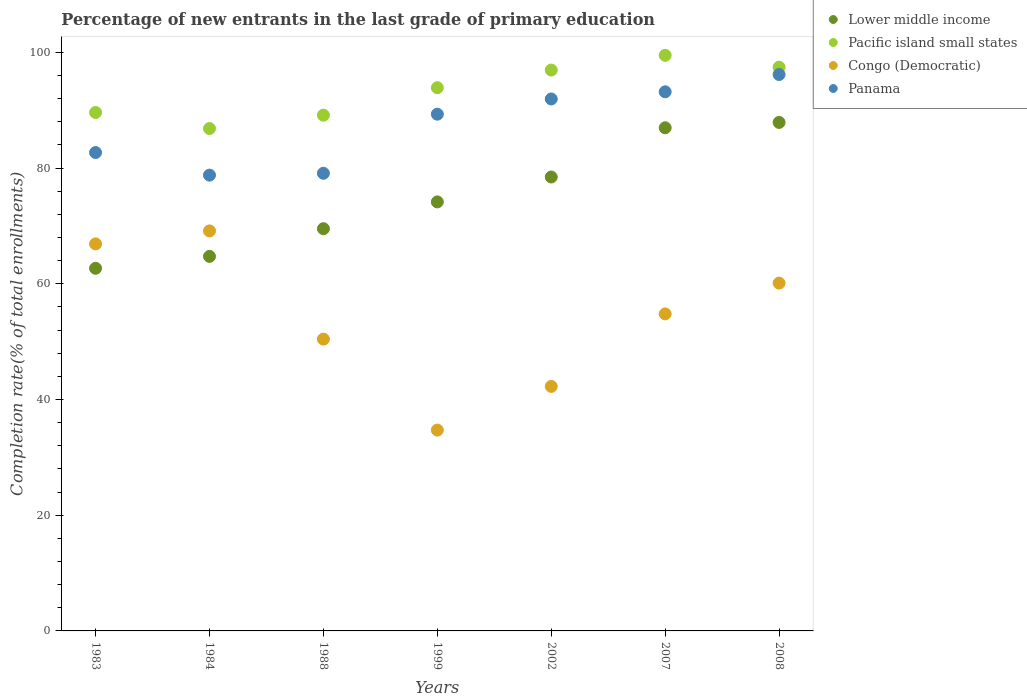Is the number of dotlines equal to the number of legend labels?
Your answer should be compact. Yes. What is the percentage of new entrants in Congo (Democratic) in 1988?
Ensure brevity in your answer.  50.44. Across all years, what is the maximum percentage of new entrants in Panama?
Provide a succinct answer. 96.17. Across all years, what is the minimum percentage of new entrants in Congo (Democratic)?
Offer a terse response. 34.71. In which year was the percentage of new entrants in Panama maximum?
Provide a short and direct response. 2008. What is the total percentage of new entrants in Panama in the graph?
Offer a very short reply. 611.19. What is the difference between the percentage of new entrants in Pacific island small states in 1983 and that in 1984?
Give a very brief answer. 2.77. What is the difference between the percentage of new entrants in Pacific island small states in 2002 and the percentage of new entrants in Lower middle income in 2007?
Your response must be concise. 9.98. What is the average percentage of new entrants in Pacific island small states per year?
Your answer should be very brief. 93.34. In the year 2002, what is the difference between the percentage of new entrants in Congo (Democratic) and percentage of new entrants in Panama?
Provide a succinct answer. -49.68. In how many years, is the percentage of new entrants in Congo (Democratic) greater than 24 %?
Keep it short and to the point. 7. What is the ratio of the percentage of new entrants in Congo (Democratic) in 1983 to that in 2002?
Your response must be concise. 1.58. Is the percentage of new entrants in Lower middle income in 1983 less than that in 1988?
Give a very brief answer. Yes. What is the difference between the highest and the second highest percentage of new entrants in Congo (Democratic)?
Keep it short and to the point. 2.25. What is the difference between the highest and the lowest percentage of new entrants in Panama?
Keep it short and to the point. 17.39. Is it the case that in every year, the sum of the percentage of new entrants in Panama and percentage of new entrants in Lower middle income  is greater than the sum of percentage of new entrants in Congo (Democratic) and percentage of new entrants in Pacific island small states?
Your answer should be very brief. No. Does the percentage of new entrants in Lower middle income monotonically increase over the years?
Your response must be concise. Yes. Is the percentage of new entrants in Congo (Democratic) strictly less than the percentage of new entrants in Panama over the years?
Provide a short and direct response. Yes. How many dotlines are there?
Your answer should be compact. 4. How many years are there in the graph?
Provide a succinct answer. 7. What is the difference between two consecutive major ticks on the Y-axis?
Your answer should be compact. 20. Are the values on the major ticks of Y-axis written in scientific E-notation?
Keep it short and to the point. No. Does the graph contain any zero values?
Provide a short and direct response. No. Where does the legend appear in the graph?
Offer a terse response. Top right. What is the title of the graph?
Offer a terse response. Percentage of new entrants in the last grade of primary education. What is the label or title of the Y-axis?
Your response must be concise. Completion rate(% of total enrollments). What is the Completion rate(% of total enrollments) in Lower middle income in 1983?
Provide a short and direct response. 62.68. What is the Completion rate(% of total enrollments) in Pacific island small states in 1983?
Keep it short and to the point. 89.61. What is the Completion rate(% of total enrollments) in Congo (Democratic) in 1983?
Ensure brevity in your answer.  66.89. What is the Completion rate(% of total enrollments) in Panama in 1983?
Provide a succinct answer. 82.69. What is the Completion rate(% of total enrollments) of Lower middle income in 1984?
Give a very brief answer. 64.73. What is the Completion rate(% of total enrollments) of Pacific island small states in 1984?
Provide a succinct answer. 86.84. What is the Completion rate(% of total enrollments) of Congo (Democratic) in 1984?
Provide a succinct answer. 69.14. What is the Completion rate(% of total enrollments) of Panama in 1984?
Offer a terse response. 78.78. What is the Completion rate(% of total enrollments) in Lower middle income in 1988?
Your answer should be very brief. 69.53. What is the Completion rate(% of total enrollments) of Pacific island small states in 1988?
Make the answer very short. 89.15. What is the Completion rate(% of total enrollments) of Congo (Democratic) in 1988?
Ensure brevity in your answer.  50.44. What is the Completion rate(% of total enrollments) in Panama in 1988?
Ensure brevity in your answer.  79.1. What is the Completion rate(% of total enrollments) in Lower middle income in 1999?
Your response must be concise. 74.16. What is the Completion rate(% of total enrollments) of Pacific island small states in 1999?
Provide a succinct answer. 93.9. What is the Completion rate(% of total enrollments) of Congo (Democratic) in 1999?
Offer a terse response. 34.71. What is the Completion rate(% of total enrollments) in Panama in 1999?
Keep it short and to the point. 89.32. What is the Completion rate(% of total enrollments) of Lower middle income in 2002?
Make the answer very short. 78.46. What is the Completion rate(% of total enrollments) of Pacific island small states in 2002?
Make the answer very short. 96.95. What is the Completion rate(% of total enrollments) of Congo (Democratic) in 2002?
Give a very brief answer. 42.26. What is the Completion rate(% of total enrollments) in Panama in 2002?
Keep it short and to the point. 91.95. What is the Completion rate(% of total enrollments) of Lower middle income in 2007?
Provide a succinct answer. 86.97. What is the Completion rate(% of total enrollments) of Pacific island small states in 2007?
Keep it short and to the point. 99.49. What is the Completion rate(% of total enrollments) in Congo (Democratic) in 2007?
Keep it short and to the point. 54.8. What is the Completion rate(% of total enrollments) in Panama in 2007?
Offer a very short reply. 93.18. What is the Completion rate(% of total enrollments) in Lower middle income in 2008?
Your answer should be compact. 87.89. What is the Completion rate(% of total enrollments) of Pacific island small states in 2008?
Offer a terse response. 97.44. What is the Completion rate(% of total enrollments) in Congo (Democratic) in 2008?
Keep it short and to the point. 60.12. What is the Completion rate(% of total enrollments) of Panama in 2008?
Give a very brief answer. 96.17. Across all years, what is the maximum Completion rate(% of total enrollments) of Lower middle income?
Your response must be concise. 87.89. Across all years, what is the maximum Completion rate(% of total enrollments) of Pacific island small states?
Keep it short and to the point. 99.49. Across all years, what is the maximum Completion rate(% of total enrollments) of Congo (Democratic)?
Keep it short and to the point. 69.14. Across all years, what is the maximum Completion rate(% of total enrollments) of Panama?
Your answer should be very brief. 96.17. Across all years, what is the minimum Completion rate(% of total enrollments) in Lower middle income?
Keep it short and to the point. 62.68. Across all years, what is the minimum Completion rate(% of total enrollments) of Pacific island small states?
Keep it short and to the point. 86.84. Across all years, what is the minimum Completion rate(% of total enrollments) in Congo (Democratic)?
Offer a very short reply. 34.71. Across all years, what is the minimum Completion rate(% of total enrollments) in Panama?
Ensure brevity in your answer.  78.78. What is the total Completion rate(% of total enrollments) in Lower middle income in the graph?
Ensure brevity in your answer.  524.41. What is the total Completion rate(% of total enrollments) of Pacific island small states in the graph?
Your answer should be very brief. 653.37. What is the total Completion rate(% of total enrollments) in Congo (Democratic) in the graph?
Ensure brevity in your answer.  378.36. What is the total Completion rate(% of total enrollments) in Panama in the graph?
Offer a terse response. 611.19. What is the difference between the Completion rate(% of total enrollments) of Lower middle income in 1983 and that in 1984?
Offer a very short reply. -2.06. What is the difference between the Completion rate(% of total enrollments) in Pacific island small states in 1983 and that in 1984?
Give a very brief answer. 2.77. What is the difference between the Completion rate(% of total enrollments) in Congo (Democratic) in 1983 and that in 1984?
Offer a very short reply. -2.25. What is the difference between the Completion rate(% of total enrollments) in Panama in 1983 and that in 1984?
Offer a terse response. 3.9. What is the difference between the Completion rate(% of total enrollments) in Lower middle income in 1983 and that in 1988?
Offer a terse response. -6.85. What is the difference between the Completion rate(% of total enrollments) of Pacific island small states in 1983 and that in 1988?
Provide a short and direct response. 0.46. What is the difference between the Completion rate(% of total enrollments) of Congo (Democratic) in 1983 and that in 1988?
Keep it short and to the point. 16.46. What is the difference between the Completion rate(% of total enrollments) in Panama in 1983 and that in 1988?
Give a very brief answer. 3.58. What is the difference between the Completion rate(% of total enrollments) of Lower middle income in 1983 and that in 1999?
Your response must be concise. -11.48. What is the difference between the Completion rate(% of total enrollments) of Pacific island small states in 1983 and that in 1999?
Keep it short and to the point. -4.28. What is the difference between the Completion rate(% of total enrollments) in Congo (Democratic) in 1983 and that in 1999?
Offer a terse response. 32.18. What is the difference between the Completion rate(% of total enrollments) in Panama in 1983 and that in 1999?
Provide a short and direct response. -6.63. What is the difference between the Completion rate(% of total enrollments) in Lower middle income in 1983 and that in 2002?
Your answer should be very brief. -15.78. What is the difference between the Completion rate(% of total enrollments) in Pacific island small states in 1983 and that in 2002?
Provide a short and direct response. -7.33. What is the difference between the Completion rate(% of total enrollments) in Congo (Democratic) in 1983 and that in 2002?
Offer a very short reply. 24.63. What is the difference between the Completion rate(% of total enrollments) in Panama in 1983 and that in 2002?
Offer a terse response. -9.26. What is the difference between the Completion rate(% of total enrollments) of Lower middle income in 1983 and that in 2007?
Your answer should be compact. -24.29. What is the difference between the Completion rate(% of total enrollments) in Pacific island small states in 1983 and that in 2007?
Your answer should be compact. -9.88. What is the difference between the Completion rate(% of total enrollments) in Congo (Democratic) in 1983 and that in 2007?
Make the answer very short. 12.1. What is the difference between the Completion rate(% of total enrollments) of Panama in 1983 and that in 2007?
Keep it short and to the point. -10.5. What is the difference between the Completion rate(% of total enrollments) in Lower middle income in 1983 and that in 2008?
Ensure brevity in your answer.  -25.21. What is the difference between the Completion rate(% of total enrollments) in Pacific island small states in 1983 and that in 2008?
Provide a succinct answer. -7.83. What is the difference between the Completion rate(% of total enrollments) of Congo (Democratic) in 1983 and that in 2008?
Keep it short and to the point. 6.78. What is the difference between the Completion rate(% of total enrollments) of Panama in 1983 and that in 2008?
Your answer should be compact. -13.49. What is the difference between the Completion rate(% of total enrollments) of Lower middle income in 1984 and that in 1988?
Your response must be concise. -4.79. What is the difference between the Completion rate(% of total enrollments) of Pacific island small states in 1984 and that in 1988?
Make the answer very short. -2.31. What is the difference between the Completion rate(% of total enrollments) in Congo (Democratic) in 1984 and that in 1988?
Provide a short and direct response. 18.71. What is the difference between the Completion rate(% of total enrollments) in Panama in 1984 and that in 1988?
Offer a very short reply. -0.32. What is the difference between the Completion rate(% of total enrollments) in Lower middle income in 1984 and that in 1999?
Give a very brief answer. -9.42. What is the difference between the Completion rate(% of total enrollments) in Pacific island small states in 1984 and that in 1999?
Your answer should be very brief. -7.06. What is the difference between the Completion rate(% of total enrollments) in Congo (Democratic) in 1984 and that in 1999?
Your answer should be compact. 34.43. What is the difference between the Completion rate(% of total enrollments) of Panama in 1984 and that in 1999?
Give a very brief answer. -10.54. What is the difference between the Completion rate(% of total enrollments) of Lower middle income in 1984 and that in 2002?
Ensure brevity in your answer.  -13.72. What is the difference between the Completion rate(% of total enrollments) in Pacific island small states in 1984 and that in 2002?
Your answer should be very brief. -10.11. What is the difference between the Completion rate(% of total enrollments) of Congo (Democratic) in 1984 and that in 2002?
Offer a terse response. 26.88. What is the difference between the Completion rate(% of total enrollments) in Panama in 1984 and that in 2002?
Offer a very short reply. -13.16. What is the difference between the Completion rate(% of total enrollments) of Lower middle income in 1984 and that in 2007?
Provide a succinct answer. -22.23. What is the difference between the Completion rate(% of total enrollments) in Pacific island small states in 1984 and that in 2007?
Provide a succinct answer. -12.65. What is the difference between the Completion rate(% of total enrollments) of Congo (Democratic) in 1984 and that in 2007?
Your answer should be compact. 14.34. What is the difference between the Completion rate(% of total enrollments) of Panama in 1984 and that in 2007?
Your answer should be compact. -14.4. What is the difference between the Completion rate(% of total enrollments) in Lower middle income in 1984 and that in 2008?
Offer a very short reply. -23.16. What is the difference between the Completion rate(% of total enrollments) of Pacific island small states in 1984 and that in 2008?
Provide a succinct answer. -10.6. What is the difference between the Completion rate(% of total enrollments) of Congo (Democratic) in 1984 and that in 2008?
Your answer should be very brief. 9.02. What is the difference between the Completion rate(% of total enrollments) of Panama in 1984 and that in 2008?
Keep it short and to the point. -17.39. What is the difference between the Completion rate(% of total enrollments) of Lower middle income in 1988 and that in 1999?
Your answer should be very brief. -4.63. What is the difference between the Completion rate(% of total enrollments) of Pacific island small states in 1988 and that in 1999?
Provide a succinct answer. -4.75. What is the difference between the Completion rate(% of total enrollments) of Congo (Democratic) in 1988 and that in 1999?
Keep it short and to the point. 15.72. What is the difference between the Completion rate(% of total enrollments) of Panama in 1988 and that in 1999?
Ensure brevity in your answer.  -10.22. What is the difference between the Completion rate(% of total enrollments) of Lower middle income in 1988 and that in 2002?
Make the answer very short. -8.93. What is the difference between the Completion rate(% of total enrollments) of Pacific island small states in 1988 and that in 2002?
Your response must be concise. -7.8. What is the difference between the Completion rate(% of total enrollments) in Congo (Democratic) in 1988 and that in 2002?
Offer a terse response. 8.17. What is the difference between the Completion rate(% of total enrollments) in Panama in 1988 and that in 2002?
Offer a terse response. -12.84. What is the difference between the Completion rate(% of total enrollments) in Lower middle income in 1988 and that in 2007?
Your response must be concise. -17.44. What is the difference between the Completion rate(% of total enrollments) of Pacific island small states in 1988 and that in 2007?
Provide a succinct answer. -10.35. What is the difference between the Completion rate(% of total enrollments) in Congo (Democratic) in 1988 and that in 2007?
Your response must be concise. -4.36. What is the difference between the Completion rate(% of total enrollments) in Panama in 1988 and that in 2007?
Your response must be concise. -14.08. What is the difference between the Completion rate(% of total enrollments) in Lower middle income in 1988 and that in 2008?
Give a very brief answer. -18.37. What is the difference between the Completion rate(% of total enrollments) of Pacific island small states in 1988 and that in 2008?
Provide a short and direct response. -8.29. What is the difference between the Completion rate(% of total enrollments) of Congo (Democratic) in 1988 and that in 2008?
Offer a terse response. -9.68. What is the difference between the Completion rate(% of total enrollments) of Panama in 1988 and that in 2008?
Provide a short and direct response. -17.07. What is the difference between the Completion rate(% of total enrollments) in Lower middle income in 1999 and that in 2002?
Keep it short and to the point. -4.3. What is the difference between the Completion rate(% of total enrollments) of Pacific island small states in 1999 and that in 2002?
Your response must be concise. -3.05. What is the difference between the Completion rate(% of total enrollments) in Congo (Democratic) in 1999 and that in 2002?
Provide a succinct answer. -7.55. What is the difference between the Completion rate(% of total enrollments) of Panama in 1999 and that in 2002?
Provide a short and direct response. -2.63. What is the difference between the Completion rate(% of total enrollments) of Lower middle income in 1999 and that in 2007?
Offer a very short reply. -12.81. What is the difference between the Completion rate(% of total enrollments) in Pacific island small states in 1999 and that in 2007?
Your response must be concise. -5.6. What is the difference between the Completion rate(% of total enrollments) in Congo (Democratic) in 1999 and that in 2007?
Offer a very short reply. -20.08. What is the difference between the Completion rate(% of total enrollments) in Panama in 1999 and that in 2007?
Ensure brevity in your answer.  -3.87. What is the difference between the Completion rate(% of total enrollments) of Lower middle income in 1999 and that in 2008?
Give a very brief answer. -13.73. What is the difference between the Completion rate(% of total enrollments) in Pacific island small states in 1999 and that in 2008?
Your response must be concise. -3.54. What is the difference between the Completion rate(% of total enrollments) in Congo (Democratic) in 1999 and that in 2008?
Give a very brief answer. -25.4. What is the difference between the Completion rate(% of total enrollments) of Panama in 1999 and that in 2008?
Keep it short and to the point. -6.86. What is the difference between the Completion rate(% of total enrollments) of Lower middle income in 2002 and that in 2007?
Provide a short and direct response. -8.51. What is the difference between the Completion rate(% of total enrollments) in Pacific island small states in 2002 and that in 2007?
Give a very brief answer. -2.55. What is the difference between the Completion rate(% of total enrollments) of Congo (Democratic) in 2002 and that in 2007?
Your answer should be compact. -12.54. What is the difference between the Completion rate(% of total enrollments) in Panama in 2002 and that in 2007?
Provide a succinct answer. -1.24. What is the difference between the Completion rate(% of total enrollments) in Lower middle income in 2002 and that in 2008?
Provide a short and direct response. -9.43. What is the difference between the Completion rate(% of total enrollments) of Pacific island small states in 2002 and that in 2008?
Your answer should be very brief. -0.49. What is the difference between the Completion rate(% of total enrollments) of Congo (Democratic) in 2002 and that in 2008?
Keep it short and to the point. -17.86. What is the difference between the Completion rate(% of total enrollments) in Panama in 2002 and that in 2008?
Ensure brevity in your answer.  -4.23. What is the difference between the Completion rate(% of total enrollments) of Lower middle income in 2007 and that in 2008?
Offer a terse response. -0.92. What is the difference between the Completion rate(% of total enrollments) in Pacific island small states in 2007 and that in 2008?
Your response must be concise. 2.05. What is the difference between the Completion rate(% of total enrollments) of Congo (Democratic) in 2007 and that in 2008?
Your answer should be very brief. -5.32. What is the difference between the Completion rate(% of total enrollments) in Panama in 2007 and that in 2008?
Offer a very short reply. -2.99. What is the difference between the Completion rate(% of total enrollments) in Lower middle income in 1983 and the Completion rate(% of total enrollments) in Pacific island small states in 1984?
Your answer should be compact. -24.16. What is the difference between the Completion rate(% of total enrollments) in Lower middle income in 1983 and the Completion rate(% of total enrollments) in Congo (Democratic) in 1984?
Your answer should be very brief. -6.46. What is the difference between the Completion rate(% of total enrollments) of Lower middle income in 1983 and the Completion rate(% of total enrollments) of Panama in 1984?
Give a very brief answer. -16.1. What is the difference between the Completion rate(% of total enrollments) of Pacific island small states in 1983 and the Completion rate(% of total enrollments) of Congo (Democratic) in 1984?
Keep it short and to the point. 20.47. What is the difference between the Completion rate(% of total enrollments) in Pacific island small states in 1983 and the Completion rate(% of total enrollments) in Panama in 1984?
Make the answer very short. 10.83. What is the difference between the Completion rate(% of total enrollments) in Congo (Democratic) in 1983 and the Completion rate(% of total enrollments) in Panama in 1984?
Keep it short and to the point. -11.89. What is the difference between the Completion rate(% of total enrollments) of Lower middle income in 1983 and the Completion rate(% of total enrollments) of Pacific island small states in 1988?
Give a very brief answer. -26.47. What is the difference between the Completion rate(% of total enrollments) in Lower middle income in 1983 and the Completion rate(% of total enrollments) in Congo (Democratic) in 1988?
Provide a succinct answer. 12.24. What is the difference between the Completion rate(% of total enrollments) in Lower middle income in 1983 and the Completion rate(% of total enrollments) in Panama in 1988?
Your response must be concise. -16.42. What is the difference between the Completion rate(% of total enrollments) in Pacific island small states in 1983 and the Completion rate(% of total enrollments) in Congo (Democratic) in 1988?
Offer a terse response. 39.18. What is the difference between the Completion rate(% of total enrollments) in Pacific island small states in 1983 and the Completion rate(% of total enrollments) in Panama in 1988?
Provide a succinct answer. 10.51. What is the difference between the Completion rate(% of total enrollments) of Congo (Democratic) in 1983 and the Completion rate(% of total enrollments) of Panama in 1988?
Offer a very short reply. -12.21. What is the difference between the Completion rate(% of total enrollments) of Lower middle income in 1983 and the Completion rate(% of total enrollments) of Pacific island small states in 1999?
Your answer should be compact. -31.22. What is the difference between the Completion rate(% of total enrollments) of Lower middle income in 1983 and the Completion rate(% of total enrollments) of Congo (Democratic) in 1999?
Provide a short and direct response. 27.97. What is the difference between the Completion rate(% of total enrollments) of Lower middle income in 1983 and the Completion rate(% of total enrollments) of Panama in 1999?
Offer a terse response. -26.64. What is the difference between the Completion rate(% of total enrollments) of Pacific island small states in 1983 and the Completion rate(% of total enrollments) of Congo (Democratic) in 1999?
Ensure brevity in your answer.  54.9. What is the difference between the Completion rate(% of total enrollments) in Pacific island small states in 1983 and the Completion rate(% of total enrollments) in Panama in 1999?
Ensure brevity in your answer.  0.29. What is the difference between the Completion rate(% of total enrollments) of Congo (Democratic) in 1983 and the Completion rate(% of total enrollments) of Panama in 1999?
Give a very brief answer. -22.42. What is the difference between the Completion rate(% of total enrollments) of Lower middle income in 1983 and the Completion rate(% of total enrollments) of Pacific island small states in 2002?
Keep it short and to the point. -34.27. What is the difference between the Completion rate(% of total enrollments) in Lower middle income in 1983 and the Completion rate(% of total enrollments) in Congo (Democratic) in 2002?
Make the answer very short. 20.42. What is the difference between the Completion rate(% of total enrollments) in Lower middle income in 1983 and the Completion rate(% of total enrollments) in Panama in 2002?
Your answer should be very brief. -29.27. What is the difference between the Completion rate(% of total enrollments) of Pacific island small states in 1983 and the Completion rate(% of total enrollments) of Congo (Democratic) in 2002?
Offer a very short reply. 47.35. What is the difference between the Completion rate(% of total enrollments) in Pacific island small states in 1983 and the Completion rate(% of total enrollments) in Panama in 2002?
Make the answer very short. -2.33. What is the difference between the Completion rate(% of total enrollments) in Congo (Democratic) in 1983 and the Completion rate(% of total enrollments) in Panama in 2002?
Your answer should be very brief. -25.05. What is the difference between the Completion rate(% of total enrollments) in Lower middle income in 1983 and the Completion rate(% of total enrollments) in Pacific island small states in 2007?
Provide a short and direct response. -36.81. What is the difference between the Completion rate(% of total enrollments) in Lower middle income in 1983 and the Completion rate(% of total enrollments) in Congo (Democratic) in 2007?
Your answer should be compact. 7.88. What is the difference between the Completion rate(% of total enrollments) in Lower middle income in 1983 and the Completion rate(% of total enrollments) in Panama in 2007?
Offer a very short reply. -30.51. What is the difference between the Completion rate(% of total enrollments) in Pacific island small states in 1983 and the Completion rate(% of total enrollments) in Congo (Democratic) in 2007?
Make the answer very short. 34.81. What is the difference between the Completion rate(% of total enrollments) of Pacific island small states in 1983 and the Completion rate(% of total enrollments) of Panama in 2007?
Your response must be concise. -3.57. What is the difference between the Completion rate(% of total enrollments) of Congo (Democratic) in 1983 and the Completion rate(% of total enrollments) of Panama in 2007?
Your answer should be very brief. -26.29. What is the difference between the Completion rate(% of total enrollments) of Lower middle income in 1983 and the Completion rate(% of total enrollments) of Pacific island small states in 2008?
Your answer should be compact. -34.76. What is the difference between the Completion rate(% of total enrollments) in Lower middle income in 1983 and the Completion rate(% of total enrollments) in Congo (Democratic) in 2008?
Give a very brief answer. 2.56. What is the difference between the Completion rate(% of total enrollments) of Lower middle income in 1983 and the Completion rate(% of total enrollments) of Panama in 2008?
Give a very brief answer. -33.5. What is the difference between the Completion rate(% of total enrollments) of Pacific island small states in 1983 and the Completion rate(% of total enrollments) of Congo (Democratic) in 2008?
Your answer should be compact. 29.49. What is the difference between the Completion rate(% of total enrollments) of Pacific island small states in 1983 and the Completion rate(% of total enrollments) of Panama in 2008?
Keep it short and to the point. -6.56. What is the difference between the Completion rate(% of total enrollments) in Congo (Democratic) in 1983 and the Completion rate(% of total enrollments) in Panama in 2008?
Your answer should be compact. -29.28. What is the difference between the Completion rate(% of total enrollments) of Lower middle income in 1984 and the Completion rate(% of total enrollments) of Pacific island small states in 1988?
Your response must be concise. -24.41. What is the difference between the Completion rate(% of total enrollments) in Lower middle income in 1984 and the Completion rate(% of total enrollments) in Congo (Democratic) in 1988?
Make the answer very short. 14.3. What is the difference between the Completion rate(% of total enrollments) of Lower middle income in 1984 and the Completion rate(% of total enrollments) of Panama in 1988?
Your response must be concise. -14.37. What is the difference between the Completion rate(% of total enrollments) in Pacific island small states in 1984 and the Completion rate(% of total enrollments) in Congo (Democratic) in 1988?
Your answer should be very brief. 36.4. What is the difference between the Completion rate(% of total enrollments) of Pacific island small states in 1984 and the Completion rate(% of total enrollments) of Panama in 1988?
Offer a very short reply. 7.73. What is the difference between the Completion rate(% of total enrollments) in Congo (Democratic) in 1984 and the Completion rate(% of total enrollments) in Panama in 1988?
Give a very brief answer. -9.96. What is the difference between the Completion rate(% of total enrollments) in Lower middle income in 1984 and the Completion rate(% of total enrollments) in Pacific island small states in 1999?
Your answer should be compact. -29.16. What is the difference between the Completion rate(% of total enrollments) of Lower middle income in 1984 and the Completion rate(% of total enrollments) of Congo (Democratic) in 1999?
Your answer should be compact. 30.02. What is the difference between the Completion rate(% of total enrollments) in Lower middle income in 1984 and the Completion rate(% of total enrollments) in Panama in 1999?
Provide a succinct answer. -24.58. What is the difference between the Completion rate(% of total enrollments) of Pacific island small states in 1984 and the Completion rate(% of total enrollments) of Congo (Democratic) in 1999?
Offer a very short reply. 52.12. What is the difference between the Completion rate(% of total enrollments) in Pacific island small states in 1984 and the Completion rate(% of total enrollments) in Panama in 1999?
Ensure brevity in your answer.  -2.48. What is the difference between the Completion rate(% of total enrollments) in Congo (Democratic) in 1984 and the Completion rate(% of total enrollments) in Panama in 1999?
Give a very brief answer. -20.18. What is the difference between the Completion rate(% of total enrollments) of Lower middle income in 1984 and the Completion rate(% of total enrollments) of Pacific island small states in 2002?
Your answer should be compact. -32.21. What is the difference between the Completion rate(% of total enrollments) of Lower middle income in 1984 and the Completion rate(% of total enrollments) of Congo (Democratic) in 2002?
Provide a succinct answer. 22.47. What is the difference between the Completion rate(% of total enrollments) in Lower middle income in 1984 and the Completion rate(% of total enrollments) in Panama in 2002?
Ensure brevity in your answer.  -27.21. What is the difference between the Completion rate(% of total enrollments) of Pacific island small states in 1984 and the Completion rate(% of total enrollments) of Congo (Democratic) in 2002?
Offer a terse response. 44.58. What is the difference between the Completion rate(% of total enrollments) of Pacific island small states in 1984 and the Completion rate(% of total enrollments) of Panama in 2002?
Ensure brevity in your answer.  -5.11. What is the difference between the Completion rate(% of total enrollments) in Congo (Democratic) in 1984 and the Completion rate(% of total enrollments) in Panama in 2002?
Offer a very short reply. -22.8. What is the difference between the Completion rate(% of total enrollments) in Lower middle income in 1984 and the Completion rate(% of total enrollments) in Pacific island small states in 2007?
Provide a short and direct response. -34.76. What is the difference between the Completion rate(% of total enrollments) in Lower middle income in 1984 and the Completion rate(% of total enrollments) in Congo (Democratic) in 2007?
Ensure brevity in your answer.  9.94. What is the difference between the Completion rate(% of total enrollments) in Lower middle income in 1984 and the Completion rate(% of total enrollments) in Panama in 2007?
Keep it short and to the point. -28.45. What is the difference between the Completion rate(% of total enrollments) in Pacific island small states in 1984 and the Completion rate(% of total enrollments) in Congo (Democratic) in 2007?
Offer a very short reply. 32.04. What is the difference between the Completion rate(% of total enrollments) in Pacific island small states in 1984 and the Completion rate(% of total enrollments) in Panama in 2007?
Offer a very short reply. -6.35. What is the difference between the Completion rate(% of total enrollments) of Congo (Democratic) in 1984 and the Completion rate(% of total enrollments) of Panama in 2007?
Ensure brevity in your answer.  -24.04. What is the difference between the Completion rate(% of total enrollments) of Lower middle income in 1984 and the Completion rate(% of total enrollments) of Pacific island small states in 2008?
Provide a short and direct response. -32.7. What is the difference between the Completion rate(% of total enrollments) in Lower middle income in 1984 and the Completion rate(% of total enrollments) in Congo (Democratic) in 2008?
Provide a short and direct response. 4.62. What is the difference between the Completion rate(% of total enrollments) in Lower middle income in 1984 and the Completion rate(% of total enrollments) in Panama in 2008?
Offer a terse response. -31.44. What is the difference between the Completion rate(% of total enrollments) of Pacific island small states in 1984 and the Completion rate(% of total enrollments) of Congo (Democratic) in 2008?
Provide a short and direct response. 26.72. What is the difference between the Completion rate(% of total enrollments) in Pacific island small states in 1984 and the Completion rate(% of total enrollments) in Panama in 2008?
Your answer should be very brief. -9.34. What is the difference between the Completion rate(% of total enrollments) of Congo (Democratic) in 1984 and the Completion rate(% of total enrollments) of Panama in 2008?
Provide a short and direct response. -27.03. What is the difference between the Completion rate(% of total enrollments) of Lower middle income in 1988 and the Completion rate(% of total enrollments) of Pacific island small states in 1999?
Offer a very short reply. -24.37. What is the difference between the Completion rate(% of total enrollments) of Lower middle income in 1988 and the Completion rate(% of total enrollments) of Congo (Democratic) in 1999?
Provide a short and direct response. 34.81. What is the difference between the Completion rate(% of total enrollments) of Lower middle income in 1988 and the Completion rate(% of total enrollments) of Panama in 1999?
Offer a terse response. -19.79. What is the difference between the Completion rate(% of total enrollments) in Pacific island small states in 1988 and the Completion rate(% of total enrollments) in Congo (Democratic) in 1999?
Keep it short and to the point. 54.43. What is the difference between the Completion rate(% of total enrollments) of Pacific island small states in 1988 and the Completion rate(% of total enrollments) of Panama in 1999?
Provide a succinct answer. -0.17. What is the difference between the Completion rate(% of total enrollments) in Congo (Democratic) in 1988 and the Completion rate(% of total enrollments) in Panama in 1999?
Offer a very short reply. -38.88. What is the difference between the Completion rate(% of total enrollments) of Lower middle income in 1988 and the Completion rate(% of total enrollments) of Pacific island small states in 2002?
Your answer should be very brief. -27.42. What is the difference between the Completion rate(% of total enrollments) of Lower middle income in 1988 and the Completion rate(% of total enrollments) of Congo (Democratic) in 2002?
Your answer should be compact. 27.26. What is the difference between the Completion rate(% of total enrollments) of Lower middle income in 1988 and the Completion rate(% of total enrollments) of Panama in 2002?
Give a very brief answer. -22.42. What is the difference between the Completion rate(% of total enrollments) in Pacific island small states in 1988 and the Completion rate(% of total enrollments) in Congo (Democratic) in 2002?
Provide a short and direct response. 46.89. What is the difference between the Completion rate(% of total enrollments) of Pacific island small states in 1988 and the Completion rate(% of total enrollments) of Panama in 2002?
Provide a succinct answer. -2.8. What is the difference between the Completion rate(% of total enrollments) in Congo (Democratic) in 1988 and the Completion rate(% of total enrollments) in Panama in 2002?
Offer a terse response. -41.51. What is the difference between the Completion rate(% of total enrollments) in Lower middle income in 1988 and the Completion rate(% of total enrollments) in Pacific island small states in 2007?
Ensure brevity in your answer.  -29.97. What is the difference between the Completion rate(% of total enrollments) of Lower middle income in 1988 and the Completion rate(% of total enrollments) of Congo (Democratic) in 2007?
Your answer should be very brief. 14.73. What is the difference between the Completion rate(% of total enrollments) in Lower middle income in 1988 and the Completion rate(% of total enrollments) in Panama in 2007?
Provide a short and direct response. -23.66. What is the difference between the Completion rate(% of total enrollments) in Pacific island small states in 1988 and the Completion rate(% of total enrollments) in Congo (Democratic) in 2007?
Make the answer very short. 34.35. What is the difference between the Completion rate(% of total enrollments) in Pacific island small states in 1988 and the Completion rate(% of total enrollments) in Panama in 2007?
Keep it short and to the point. -4.04. What is the difference between the Completion rate(% of total enrollments) of Congo (Democratic) in 1988 and the Completion rate(% of total enrollments) of Panama in 2007?
Your answer should be compact. -42.75. What is the difference between the Completion rate(% of total enrollments) of Lower middle income in 1988 and the Completion rate(% of total enrollments) of Pacific island small states in 2008?
Your answer should be very brief. -27.91. What is the difference between the Completion rate(% of total enrollments) of Lower middle income in 1988 and the Completion rate(% of total enrollments) of Congo (Democratic) in 2008?
Ensure brevity in your answer.  9.41. What is the difference between the Completion rate(% of total enrollments) in Lower middle income in 1988 and the Completion rate(% of total enrollments) in Panama in 2008?
Offer a terse response. -26.65. What is the difference between the Completion rate(% of total enrollments) in Pacific island small states in 1988 and the Completion rate(% of total enrollments) in Congo (Democratic) in 2008?
Your answer should be compact. 29.03. What is the difference between the Completion rate(% of total enrollments) of Pacific island small states in 1988 and the Completion rate(% of total enrollments) of Panama in 2008?
Your answer should be very brief. -7.03. What is the difference between the Completion rate(% of total enrollments) in Congo (Democratic) in 1988 and the Completion rate(% of total enrollments) in Panama in 2008?
Ensure brevity in your answer.  -45.74. What is the difference between the Completion rate(% of total enrollments) of Lower middle income in 1999 and the Completion rate(% of total enrollments) of Pacific island small states in 2002?
Offer a very short reply. -22.79. What is the difference between the Completion rate(% of total enrollments) in Lower middle income in 1999 and the Completion rate(% of total enrollments) in Congo (Democratic) in 2002?
Give a very brief answer. 31.89. What is the difference between the Completion rate(% of total enrollments) in Lower middle income in 1999 and the Completion rate(% of total enrollments) in Panama in 2002?
Your answer should be very brief. -17.79. What is the difference between the Completion rate(% of total enrollments) of Pacific island small states in 1999 and the Completion rate(% of total enrollments) of Congo (Democratic) in 2002?
Provide a succinct answer. 51.63. What is the difference between the Completion rate(% of total enrollments) of Pacific island small states in 1999 and the Completion rate(% of total enrollments) of Panama in 2002?
Your answer should be very brief. 1.95. What is the difference between the Completion rate(% of total enrollments) of Congo (Democratic) in 1999 and the Completion rate(% of total enrollments) of Panama in 2002?
Your answer should be very brief. -57.23. What is the difference between the Completion rate(% of total enrollments) in Lower middle income in 1999 and the Completion rate(% of total enrollments) in Pacific island small states in 2007?
Keep it short and to the point. -25.34. What is the difference between the Completion rate(% of total enrollments) of Lower middle income in 1999 and the Completion rate(% of total enrollments) of Congo (Democratic) in 2007?
Keep it short and to the point. 19.36. What is the difference between the Completion rate(% of total enrollments) in Lower middle income in 1999 and the Completion rate(% of total enrollments) in Panama in 2007?
Your answer should be compact. -19.03. What is the difference between the Completion rate(% of total enrollments) in Pacific island small states in 1999 and the Completion rate(% of total enrollments) in Congo (Democratic) in 2007?
Make the answer very short. 39.1. What is the difference between the Completion rate(% of total enrollments) of Pacific island small states in 1999 and the Completion rate(% of total enrollments) of Panama in 2007?
Your response must be concise. 0.71. What is the difference between the Completion rate(% of total enrollments) of Congo (Democratic) in 1999 and the Completion rate(% of total enrollments) of Panama in 2007?
Ensure brevity in your answer.  -58.47. What is the difference between the Completion rate(% of total enrollments) of Lower middle income in 1999 and the Completion rate(% of total enrollments) of Pacific island small states in 2008?
Offer a very short reply. -23.28. What is the difference between the Completion rate(% of total enrollments) in Lower middle income in 1999 and the Completion rate(% of total enrollments) in Congo (Democratic) in 2008?
Give a very brief answer. 14.04. What is the difference between the Completion rate(% of total enrollments) of Lower middle income in 1999 and the Completion rate(% of total enrollments) of Panama in 2008?
Provide a short and direct response. -22.02. What is the difference between the Completion rate(% of total enrollments) of Pacific island small states in 1999 and the Completion rate(% of total enrollments) of Congo (Democratic) in 2008?
Offer a very short reply. 33.78. What is the difference between the Completion rate(% of total enrollments) of Pacific island small states in 1999 and the Completion rate(% of total enrollments) of Panama in 2008?
Provide a succinct answer. -2.28. What is the difference between the Completion rate(% of total enrollments) in Congo (Democratic) in 1999 and the Completion rate(% of total enrollments) in Panama in 2008?
Your response must be concise. -61.46. What is the difference between the Completion rate(% of total enrollments) in Lower middle income in 2002 and the Completion rate(% of total enrollments) in Pacific island small states in 2007?
Your response must be concise. -21.04. What is the difference between the Completion rate(% of total enrollments) in Lower middle income in 2002 and the Completion rate(% of total enrollments) in Congo (Democratic) in 2007?
Your response must be concise. 23.66. What is the difference between the Completion rate(% of total enrollments) in Lower middle income in 2002 and the Completion rate(% of total enrollments) in Panama in 2007?
Your answer should be compact. -14.73. What is the difference between the Completion rate(% of total enrollments) of Pacific island small states in 2002 and the Completion rate(% of total enrollments) of Congo (Democratic) in 2007?
Make the answer very short. 42.15. What is the difference between the Completion rate(% of total enrollments) in Pacific island small states in 2002 and the Completion rate(% of total enrollments) in Panama in 2007?
Your answer should be very brief. 3.76. What is the difference between the Completion rate(% of total enrollments) of Congo (Democratic) in 2002 and the Completion rate(% of total enrollments) of Panama in 2007?
Offer a terse response. -50.92. What is the difference between the Completion rate(% of total enrollments) of Lower middle income in 2002 and the Completion rate(% of total enrollments) of Pacific island small states in 2008?
Offer a terse response. -18.98. What is the difference between the Completion rate(% of total enrollments) of Lower middle income in 2002 and the Completion rate(% of total enrollments) of Congo (Democratic) in 2008?
Offer a terse response. 18.34. What is the difference between the Completion rate(% of total enrollments) in Lower middle income in 2002 and the Completion rate(% of total enrollments) in Panama in 2008?
Provide a succinct answer. -17.72. What is the difference between the Completion rate(% of total enrollments) in Pacific island small states in 2002 and the Completion rate(% of total enrollments) in Congo (Democratic) in 2008?
Your response must be concise. 36.83. What is the difference between the Completion rate(% of total enrollments) of Pacific island small states in 2002 and the Completion rate(% of total enrollments) of Panama in 2008?
Offer a very short reply. 0.77. What is the difference between the Completion rate(% of total enrollments) in Congo (Democratic) in 2002 and the Completion rate(% of total enrollments) in Panama in 2008?
Offer a very short reply. -53.91. What is the difference between the Completion rate(% of total enrollments) in Lower middle income in 2007 and the Completion rate(% of total enrollments) in Pacific island small states in 2008?
Offer a very short reply. -10.47. What is the difference between the Completion rate(% of total enrollments) in Lower middle income in 2007 and the Completion rate(% of total enrollments) in Congo (Democratic) in 2008?
Offer a terse response. 26.85. What is the difference between the Completion rate(% of total enrollments) of Lower middle income in 2007 and the Completion rate(% of total enrollments) of Panama in 2008?
Provide a succinct answer. -9.21. What is the difference between the Completion rate(% of total enrollments) in Pacific island small states in 2007 and the Completion rate(% of total enrollments) in Congo (Democratic) in 2008?
Your answer should be very brief. 39.37. What is the difference between the Completion rate(% of total enrollments) of Pacific island small states in 2007 and the Completion rate(% of total enrollments) of Panama in 2008?
Keep it short and to the point. 3.32. What is the difference between the Completion rate(% of total enrollments) of Congo (Democratic) in 2007 and the Completion rate(% of total enrollments) of Panama in 2008?
Your response must be concise. -41.38. What is the average Completion rate(% of total enrollments) in Lower middle income per year?
Provide a short and direct response. 74.92. What is the average Completion rate(% of total enrollments) in Pacific island small states per year?
Offer a very short reply. 93.34. What is the average Completion rate(% of total enrollments) in Congo (Democratic) per year?
Ensure brevity in your answer.  54.05. What is the average Completion rate(% of total enrollments) of Panama per year?
Give a very brief answer. 87.31. In the year 1983, what is the difference between the Completion rate(% of total enrollments) in Lower middle income and Completion rate(% of total enrollments) in Pacific island small states?
Give a very brief answer. -26.93. In the year 1983, what is the difference between the Completion rate(% of total enrollments) of Lower middle income and Completion rate(% of total enrollments) of Congo (Democratic)?
Offer a very short reply. -4.22. In the year 1983, what is the difference between the Completion rate(% of total enrollments) in Lower middle income and Completion rate(% of total enrollments) in Panama?
Provide a succinct answer. -20.01. In the year 1983, what is the difference between the Completion rate(% of total enrollments) in Pacific island small states and Completion rate(% of total enrollments) in Congo (Democratic)?
Provide a short and direct response. 22.72. In the year 1983, what is the difference between the Completion rate(% of total enrollments) of Pacific island small states and Completion rate(% of total enrollments) of Panama?
Give a very brief answer. 6.93. In the year 1983, what is the difference between the Completion rate(% of total enrollments) in Congo (Democratic) and Completion rate(% of total enrollments) in Panama?
Provide a succinct answer. -15.79. In the year 1984, what is the difference between the Completion rate(% of total enrollments) of Lower middle income and Completion rate(% of total enrollments) of Pacific island small states?
Your answer should be very brief. -22.1. In the year 1984, what is the difference between the Completion rate(% of total enrollments) of Lower middle income and Completion rate(% of total enrollments) of Congo (Democratic)?
Make the answer very short. -4.41. In the year 1984, what is the difference between the Completion rate(% of total enrollments) in Lower middle income and Completion rate(% of total enrollments) in Panama?
Make the answer very short. -14.05. In the year 1984, what is the difference between the Completion rate(% of total enrollments) in Pacific island small states and Completion rate(% of total enrollments) in Congo (Democratic)?
Your answer should be very brief. 17.7. In the year 1984, what is the difference between the Completion rate(% of total enrollments) in Pacific island small states and Completion rate(% of total enrollments) in Panama?
Offer a very short reply. 8.06. In the year 1984, what is the difference between the Completion rate(% of total enrollments) in Congo (Democratic) and Completion rate(% of total enrollments) in Panama?
Provide a short and direct response. -9.64. In the year 1988, what is the difference between the Completion rate(% of total enrollments) of Lower middle income and Completion rate(% of total enrollments) of Pacific island small states?
Offer a very short reply. -19.62. In the year 1988, what is the difference between the Completion rate(% of total enrollments) in Lower middle income and Completion rate(% of total enrollments) in Congo (Democratic)?
Give a very brief answer. 19.09. In the year 1988, what is the difference between the Completion rate(% of total enrollments) in Lower middle income and Completion rate(% of total enrollments) in Panama?
Ensure brevity in your answer.  -9.58. In the year 1988, what is the difference between the Completion rate(% of total enrollments) in Pacific island small states and Completion rate(% of total enrollments) in Congo (Democratic)?
Your answer should be very brief. 38.71. In the year 1988, what is the difference between the Completion rate(% of total enrollments) of Pacific island small states and Completion rate(% of total enrollments) of Panama?
Offer a terse response. 10.04. In the year 1988, what is the difference between the Completion rate(% of total enrollments) of Congo (Democratic) and Completion rate(% of total enrollments) of Panama?
Offer a terse response. -28.67. In the year 1999, what is the difference between the Completion rate(% of total enrollments) in Lower middle income and Completion rate(% of total enrollments) in Pacific island small states?
Offer a very short reply. -19.74. In the year 1999, what is the difference between the Completion rate(% of total enrollments) in Lower middle income and Completion rate(% of total enrollments) in Congo (Democratic)?
Make the answer very short. 39.44. In the year 1999, what is the difference between the Completion rate(% of total enrollments) of Lower middle income and Completion rate(% of total enrollments) of Panama?
Provide a short and direct response. -15.16. In the year 1999, what is the difference between the Completion rate(% of total enrollments) of Pacific island small states and Completion rate(% of total enrollments) of Congo (Democratic)?
Offer a terse response. 59.18. In the year 1999, what is the difference between the Completion rate(% of total enrollments) of Pacific island small states and Completion rate(% of total enrollments) of Panama?
Your answer should be very brief. 4.58. In the year 1999, what is the difference between the Completion rate(% of total enrollments) in Congo (Democratic) and Completion rate(% of total enrollments) in Panama?
Your answer should be compact. -54.6. In the year 2002, what is the difference between the Completion rate(% of total enrollments) of Lower middle income and Completion rate(% of total enrollments) of Pacific island small states?
Your answer should be compact. -18.49. In the year 2002, what is the difference between the Completion rate(% of total enrollments) of Lower middle income and Completion rate(% of total enrollments) of Congo (Democratic)?
Your response must be concise. 36.2. In the year 2002, what is the difference between the Completion rate(% of total enrollments) of Lower middle income and Completion rate(% of total enrollments) of Panama?
Offer a very short reply. -13.49. In the year 2002, what is the difference between the Completion rate(% of total enrollments) in Pacific island small states and Completion rate(% of total enrollments) in Congo (Democratic)?
Make the answer very short. 54.68. In the year 2002, what is the difference between the Completion rate(% of total enrollments) in Pacific island small states and Completion rate(% of total enrollments) in Panama?
Keep it short and to the point. 5. In the year 2002, what is the difference between the Completion rate(% of total enrollments) of Congo (Democratic) and Completion rate(% of total enrollments) of Panama?
Ensure brevity in your answer.  -49.68. In the year 2007, what is the difference between the Completion rate(% of total enrollments) in Lower middle income and Completion rate(% of total enrollments) in Pacific island small states?
Your answer should be compact. -12.52. In the year 2007, what is the difference between the Completion rate(% of total enrollments) of Lower middle income and Completion rate(% of total enrollments) of Congo (Democratic)?
Keep it short and to the point. 32.17. In the year 2007, what is the difference between the Completion rate(% of total enrollments) in Lower middle income and Completion rate(% of total enrollments) in Panama?
Provide a short and direct response. -6.22. In the year 2007, what is the difference between the Completion rate(% of total enrollments) in Pacific island small states and Completion rate(% of total enrollments) in Congo (Democratic)?
Keep it short and to the point. 44.7. In the year 2007, what is the difference between the Completion rate(% of total enrollments) of Pacific island small states and Completion rate(% of total enrollments) of Panama?
Ensure brevity in your answer.  6.31. In the year 2007, what is the difference between the Completion rate(% of total enrollments) of Congo (Democratic) and Completion rate(% of total enrollments) of Panama?
Your answer should be very brief. -38.39. In the year 2008, what is the difference between the Completion rate(% of total enrollments) of Lower middle income and Completion rate(% of total enrollments) of Pacific island small states?
Offer a terse response. -9.55. In the year 2008, what is the difference between the Completion rate(% of total enrollments) of Lower middle income and Completion rate(% of total enrollments) of Congo (Democratic)?
Provide a short and direct response. 27.77. In the year 2008, what is the difference between the Completion rate(% of total enrollments) in Lower middle income and Completion rate(% of total enrollments) in Panama?
Your answer should be very brief. -8.28. In the year 2008, what is the difference between the Completion rate(% of total enrollments) in Pacific island small states and Completion rate(% of total enrollments) in Congo (Democratic)?
Give a very brief answer. 37.32. In the year 2008, what is the difference between the Completion rate(% of total enrollments) in Pacific island small states and Completion rate(% of total enrollments) in Panama?
Your response must be concise. 1.26. In the year 2008, what is the difference between the Completion rate(% of total enrollments) in Congo (Democratic) and Completion rate(% of total enrollments) in Panama?
Your answer should be very brief. -36.06. What is the ratio of the Completion rate(% of total enrollments) of Lower middle income in 1983 to that in 1984?
Make the answer very short. 0.97. What is the ratio of the Completion rate(% of total enrollments) of Pacific island small states in 1983 to that in 1984?
Your answer should be very brief. 1.03. What is the ratio of the Completion rate(% of total enrollments) in Congo (Democratic) in 1983 to that in 1984?
Make the answer very short. 0.97. What is the ratio of the Completion rate(% of total enrollments) in Panama in 1983 to that in 1984?
Give a very brief answer. 1.05. What is the ratio of the Completion rate(% of total enrollments) of Lower middle income in 1983 to that in 1988?
Your answer should be compact. 0.9. What is the ratio of the Completion rate(% of total enrollments) in Pacific island small states in 1983 to that in 1988?
Ensure brevity in your answer.  1.01. What is the ratio of the Completion rate(% of total enrollments) of Congo (Democratic) in 1983 to that in 1988?
Ensure brevity in your answer.  1.33. What is the ratio of the Completion rate(% of total enrollments) of Panama in 1983 to that in 1988?
Keep it short and to the point. 1.05. What is the ratio of the Completion rate(% of total enrollments) in Lower middle income in 1983 to that in 1999?
Your answer should be compact. 0.85. What is the ratio of the Completion rate(% of total enrollments) in Pacific island small states in 1983 to that in 1999?
Provide a succinct answer. 0.95. What is the ratio of the Completion rate(% of total enrollments) in Congo (Democratic) in 1983 to that in 1999?
Your answer should be very brief. 1.93. What is the ratio of the Completion rate(% of total enrollments) of Panama in 1983 to that in 1999?
Provide a short and direct response. 0.93. What is the ratio of the Completion rate(% of total enrollments) in Lower middle income in 1983 to that in 2002?
Offer a terse response. 0.8. What is the ratio of the Completion rate(% of total enrollments) in Pacific island small states in 1983 to that in 2002?
Provide a short and direct response. 0.92. What is the ratio of the Completion rate(% of total enrollments) of Congo (Democratic) in 1983 to that in 2002?
Give a very brief answer. 1.58. What is the ratio of the Completion rate(% of total enrollments) in Panama in 1983 to that in 2002?
Offer a terse response. 0.9. What is the ratio of the Completion rate(% of total enrollments) in Lower middle income in 1983 to that in 2007?
Provide a succinct answer. 0.72. What is the ratio of the Completion rate(% of total enrollments) of Pacific island small states in 1983 to that in 2007?
Make the answer very short. 0.9. What is the ratio of the Completion rate(% of total enrollments) of Congo (Democratic) in 1983 to that in 2007?
Your answer should be very brief. 1.22. What is the ratio of the Completion rate(% of total enrollments) of Panama in 1983 to that in 2007?
Ensure brevity in your answer.  0.89. What is the ratio of the Completion rate(% of total enrollments) in Lower middle income in 1983 to that in 2008?
Offer a very short reply. 0.71. What is the ratio of the Completion rate(% of total enrollments) of Pacific island small states in 1983 to that in 2008?
Make the answer very short. 0.92. What is the ratio of the Completion rate(% of total enrollments) in Congo (Democratic) in 1983 to that in 2008?
Your response must be concise. 1.11. What is the ratio of the Completion rate(% of total enrollments) of Panama in 1983 to that in 2008?
Offer a very short reply. 0.86. What is the ratio of the Completion rate(% of total enrollments) of Lower middle income in 1984 to that in 1988?
Ensure brevity in your answer.  0.93. What is the ratio of the Completion rate(% of total enrollments) in Pacific island small states in 1984 to that in 1988?
Offer a terse response. 0.97. What is the ratio of the Completion rate(% of total enrollments) in Congo (Democratic) in 1984 to that in 1988?
Give a very brief answer. 1.37. What is the ratio of the Completion rate(% of total enrollments) in Lower middle income in 1984 to that in 1999?
Your answer should be compact. 0.87. What is the ratio of the Completion rate(% of total enrollments) in Pacific island small states in 1984 to that in 1999?
Offer a terse response. 0.92. What is the ratio of the Completion rate(% of total enrollments) of Congo (Democratic) in 1984 to that in 1999?
Provide a succinct answer. 1.99. What is the ratio of the Completion rate(% of total enrollments) of Panama in 1984 to that in 1999?
Keep it short and to the point. 0.88. What is the ratio of the Completion rate(% of total enrollments) of Lower middle income in 1984 to that in 2002?
Offer a very short reply. 0.83. What is the ratio of the Completion rate(% of total enrollments) in Pacific island small states in 1984 to that in 2002?
Keep it short and to the point. 0.9. What is the ratio of the Completion rate(% of total enrollments) in Congo (Democratic) in 1984 to that in 2002?
Your answer should be compact. 1.64. What is the ratio of the Completion rate(% of total enrollments) of Panama in 1984 to that in 2002?
Keep it short and to the point. 0.86. What is the ratio of the Completion rate(% of total enrollments) of Lower middle income in 1984 to that in 2007?
Your answer should be very brief. 0.74. What is the ratio of the Completion rate(% of total enrollments) in Pacific island small states in 1984 to that in 2007?
Give a very brief answer. 0.87. What is the ratio of the Completion rate(% of total enrollments) in Congo (Democratic) in 1984 to that in 2007?
Offer a terse response. 1.26. What is the ratio of the Completion rate(% of total enrollments) in Panama in 1984 to that in 2007?
Give a very brief answer. 0.85. What is the ratio of the Completion rate(% of total enrollments) in Lower middle income in 1984 to that in 2008?
Keep it short and to the point. 0.74. What is the ratio of the Completion rate(% of total enrollments) in Pacific island small states in 1984 to that in 2008?
Your answer should be compact. 0.89. What is the ratio of the Completion rate(% of total enrollments) of Congo (Democratic) in 1984 to that in 2008?
Provide a short and direct response. 1.15. What is the ratio of the Completion rate(% of total enrollments) in Panama in 1984 to that in 2008?
Offer a terse response. 0.82. What is the ratio of the Completion rate(% of total enrollments) in Lower middle income in 1988 to that in 1999?
Ensure brevity in your answer.  0.94. What is the ratio of the Completion rate(% of total enrollments) of Pacific island small states in 1988 to that in 1999?
Provide a succinct answer. 0.95. What is the ratio of the Completion rate(% of total enrollments) of Congo (Democratic) in 1988 to that in 1999?
Offer a terse response. 1.45. What is the ratio of the Completion rate(% of total enrollments) of Panama in 1988 to that in 1999?
Your answer should be very brief. 0.89. What is the ratio of the Completion rate(% of total enrollments) in Lower middle income in 1988 to that in 2002?
Provide a succinct answer. 0.89. What is the ratio of the Completion rate(% of total enrollments) of Pacific island small states in 1988 to that in 2002?
Your answer should be compact. 0.92. What is the ratio of the Completion rate(% of total enrollments) in Congo (Democratic) in 1988 to that in 2002?
Keep it short and to the point. 1.19. What is the ratio of the Completion rate(% of total enrollments) of Panama in 1988 to that in 2002?
Your answer should be compact. 0.86. What is the ratio of the Completion rate(% of total enrollments) in Lower middle income in 1988 to that in 2007?
Your answer should be very brief. 0.8. What is the ratio of the Completion rate(% of total enrollments) of Pacific island small states in 1988 to that in 2007?
Give a very brief answer. 0.9. What is the ratio of the Completion rate(% of total enrollments) of Congo (Democratic) in 1988 to that in 2007?
Offer a terse response. 0.92. What is the ratio of the Completion rate(% of total enrollments) of Panama in 1988 to that in 2007?
Give a very brief answer. 0.85. What is the ratio of the Completion rate(% of total enrollments) of Lower middle income in 1988 to that in 2008?
Your answer should be compact. 0.79. What is the ratio of the Completion rate(% of total enrollments) in Pacific island small states in 1988 to that in 2008?
Keep it short and to the point. 0.91. What is the ratio of the Completion rate(% of total enrollments) of Congo (Democratic) in 1988 to that in 2008?
Make the answer very short. 0.84. What is the ratio of the Completion rate(% of total enrollments) in Panama in 1988 to that in 2008?
Your response must be concise. 0.82. What is the ratio of the Completion rate(% of total enrollments) of Lower middle income in 1999 to that in 2002?
Provide a succinct answer. 0.95. What is the ratio of the Completion rate(% of total enrollments) in Pacific island small states in 1999 to that in 2002?
Ensure brevity in your answer.  0.97. What is the ratio of the Completion rate(% of total enrollments) in Congo (Democratic) in 1999 to that in 2002?
Give a very brief answer. 0.82. What is the ratio of the Completion rate(% of total enrollments) in Panama in 1999 to that in 2002?
Keep it short and to the point. 0.97. What is the ratio of the Completion rate(% of total enrollments) of Lower middle income in 1999 to that in 2007?
Your answer should be compact. 0.85. What is the ratio of the Completion rate(% of total enrollments) of Pacific island small states in 1999 to that in 2007?
Your answer should be compact. 0.94. What is the ratio of the Completion rate(% of total enrollments) in Congo (Democratic) in 1999 to that in 2007?
Your response must be concise. 0.63. What is the ratio of the Completion rate(% of total enrollments) in Panama in 1999 to that in 2007?
Give a very brief answer. 0.96. What is the ratio of the Completion rate(% of total enrollments) in Lower middle income in 1999 to that in 2008?
Make the answer very short. 0.84. What is the ratio of the Completion rate(% of total enrollments) in Pacific island small states in 1999 to that in 2008?
Offer a terse response. 0.96. What is the ratio of the Completion rate(% of total enrollments) in Congo (Democratic) in 1999 to that in 2008?
Provide a short and direct response. 0.58. What is the ratio of the Completion rate(% of total enrollments) in Panama in 1999 to that in 2008?
Ensure brevity in your answer.  0.93. What is the ratio of the Completion rate(% of total enrollments) of Lower middle income in 2002 to that in 2007?
Offer a very short reply. 0.9. What is the ratio of the Completion rate(% of total enrollments) in Pacific island small states in 2002 to that in 2007?
Keep it short and to the point. 0.97. What is the ratio of the Completion rate(% of total enrollments) in Congo (Democratic) in 2002 to that in 2007?
Your answer should be compact. 0.77. What is the ratio of the Completion rate(% of total enrollments) of Panama in 2002 to that in 2007?
Make the answer very short. 0.99. What is the ratio of the Completion rate(% of total enrollments) in Lower middle income in 2002 to that in 2008?
Give a very brief answer. 0.89. What is the ratio of the Completion rate(% of total enrollments) in Congo (Democratic) in 2002 to that in 2008?
Provide a short and direct response. 0.7. What is the ratio of the Completion rate(% of total enrollments) in Panama in 2002 to that in 2008?
Your answer should be compact. 0.96. What is the ratio of the Completion rate(% of total enrollments) in Lower middle income in 2007 to that in 2008?
Your answer should be very brief. 0.99. What is the ratio of the Completion rate(% of total enrollments) of Pacific island small states in 2007 to that in 2008?
Offer a very short reply. 1.02. What is the ratio of the Completion rate(% of total enrollments) in Congo (Democratic) in 2007 to that in 2008?
Make the answer very short. 0.91. What is the ratio of the Completion rate(% of total enrollments) of Panama in 2007 to that in 2008?
Provide a short and direct response. 0.97. What is the difference between the highest and the second highest Completion rate(% of total enrollments) of Lower middle income?
Provide a succinct answer. 0.92. What is the difference between the highest and the second highest Completion rate(% of total enrollments) in Pacific island small states?
Your answer should be compact. 2.05. What is the difference between the highest and the second highest Completion rate(% of total enrollments) of Congo (Democratic)?
Provide a succinct answer. 2.25. What is the difference between the highest and the second highest Completion rate(% of total enrollments) in Panama?
Offer a very short reply. 2.99. What is the difference between the highest and the lowest Completion rate(% of total enrollments) in Lower middle income?
Your response must be concise. 25.21. What is the difference between the highest and the lowest Completion rate(% of total enrollments) of Pacific island small states?
Offer a very short reply. 12.65. What is the difference between the highest and the lowest Completion rate(% of total enrollments) in Congo (Democratic)?
Your answer should be compact. 34.43. What is the difference between the highest and the lowest Completion rate(% of total enrollments) in Panama?
Your response must be concise. 17.39. 